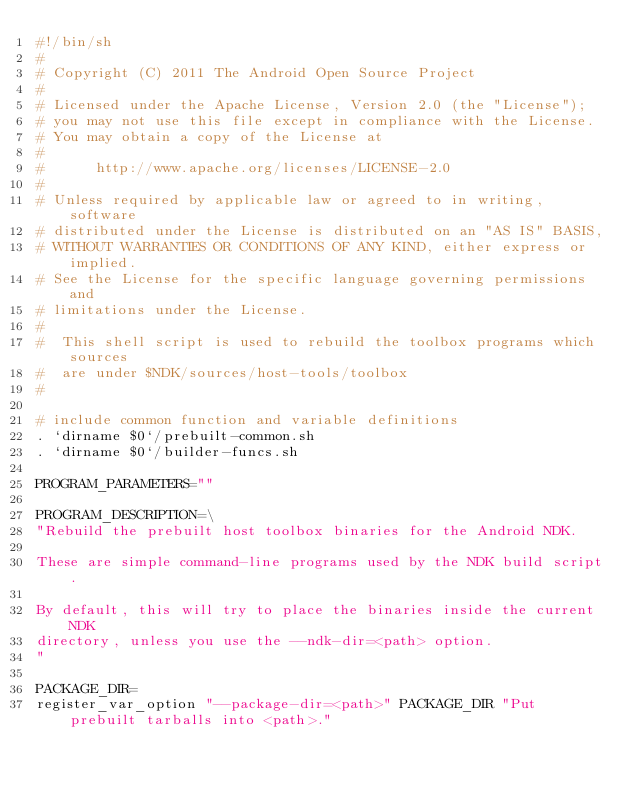Convert code to text. <code><loc_0><loc_0><loc_500><loc_500><_Bash_>#!/bin/sh
#
# Copyright (C) 2011 The Android Open Source Project
#
# Licensed under the Apache License, Version 2.0 (the "License");
# you may not use this file except in compliance with the License.
# You may obtain a copy of the License at
#
#      http://www.apache.org/licenses/LICENSE-2.0
#
# Unless required by applicable law or agreed to in writing, software
# distributed under the License is distributed on an "AS IS" BASIS,
# WITHOUT WARRANTIES OR CONDITIONS OF ANY KIND, either express or implied.
# See the License for the specific language governing permissions and
# limitations under the License.
#
#  This shell script is used to rebuild the toolbox programs which sources
#  are under $NDK/sources/host-tools/toolbox
#

# include common function and variable definitions
. `dirname $0`/prebuilt-common.sh
. `dirname $0`/builder-funcs.sh

PROGRAM_PARAMETERS=""

PROGRAM_DESCRIPTION=\
"Rebuild the prebuilt host toolbox binaries for the Android NDK.

These are simple command-line programs used by the NDK build script.

By default, this will try to place the binaries inside the current NDK
directory, unless you use the --ndk-dir=<path> option.
"

PACKAGE_DIR=
register_var_option "--package-dir=<path>" PACKAGE_DIR "Put prebuilt tarballs into <path>."
</code> 